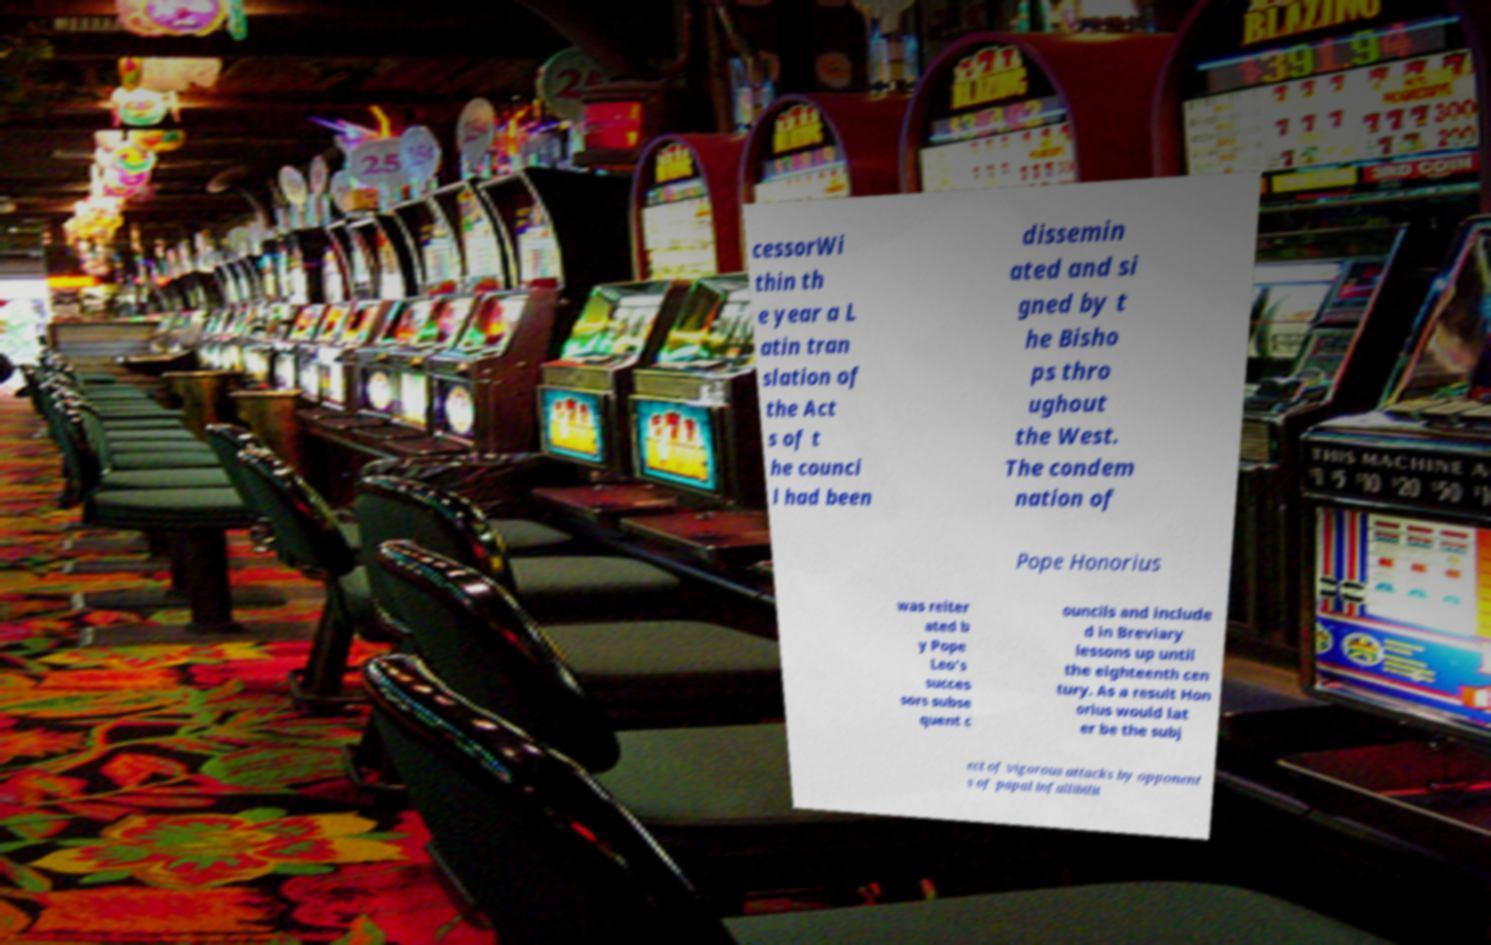Please identify and transcribe the text found in this image. cessorWi thin th e year a L atin tran slation of the Act s of t he counci l had been dissemin ated and si gned by t he Bisho ps thro ughout the West. The condem nation of Pope Honorius was reiter ated b y Pope Leo's succes sors subse quent c ouncils and include d in Breviary lessons up until the eighteenth cen tury. As a result Hon orius would lat er be the subj ect of vigorous attacks by opponent s of papal infallibilit 